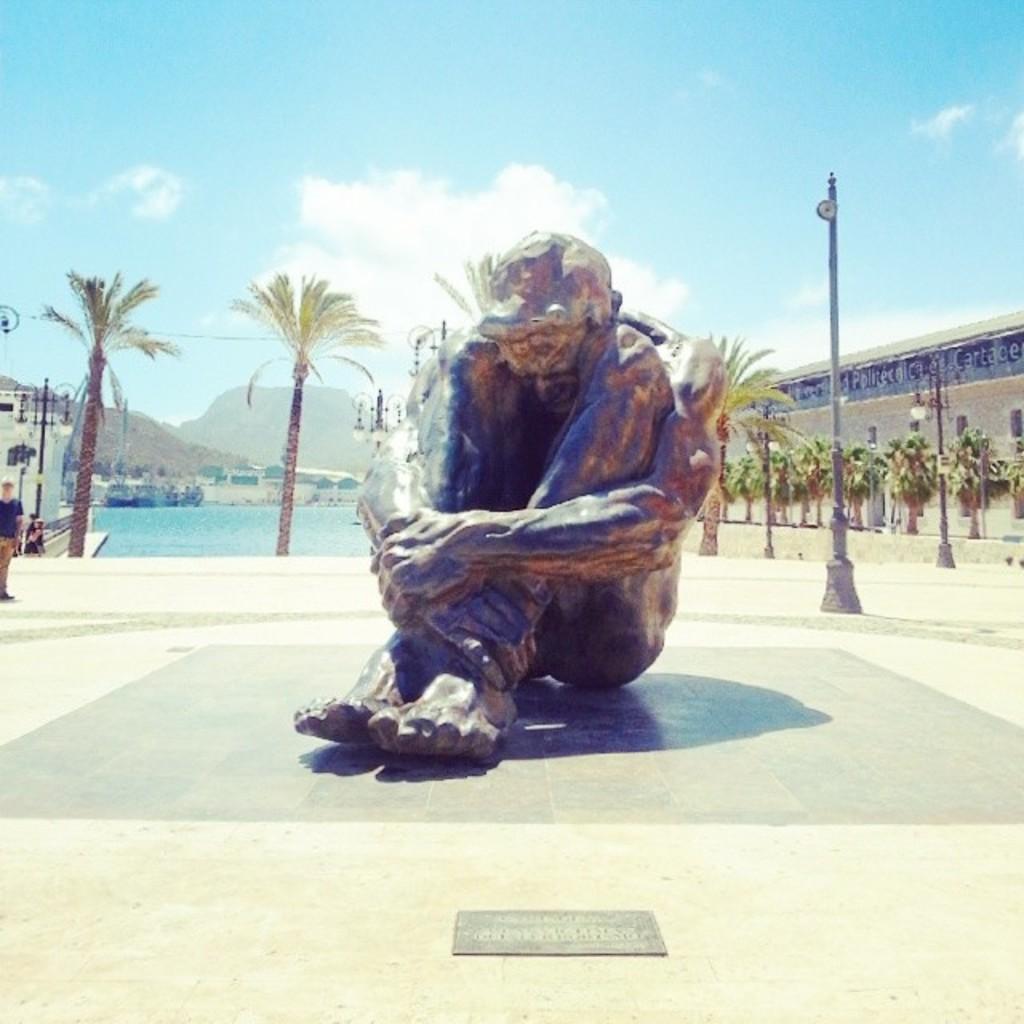Can you describe this image briefly? In this image we can see the mountains, two buildings, some trees, one person sitting, some lights with pole, one man standing, some objects on the water looks like boats, some objects on the ground, one wire, one statue on the floor, one board with text near the statue and at the top there is the sky. 